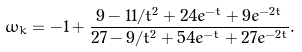Convert formula to latex. <formula><loc_0><loc_0><loc_500><loc_500>\omega _ { k } = - 1 + \frac { 9 - 1 1 / t ^ { 2 } + 2 4 e ^ { - t } + 9 e ^ { - 2 t } } { 2 7 - 9 / t ^ { 2 } + 5 4 e ^ { - t } + 2 7 e ^ { - 2 t } } .</formula> 